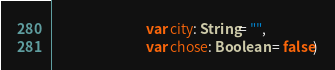Convert code to text. <code><loc_0><loc_0><loc_500><loc_500><_Kotlin_>                              var city: String= "",
                              var chose: Boolean = false)
</code> 